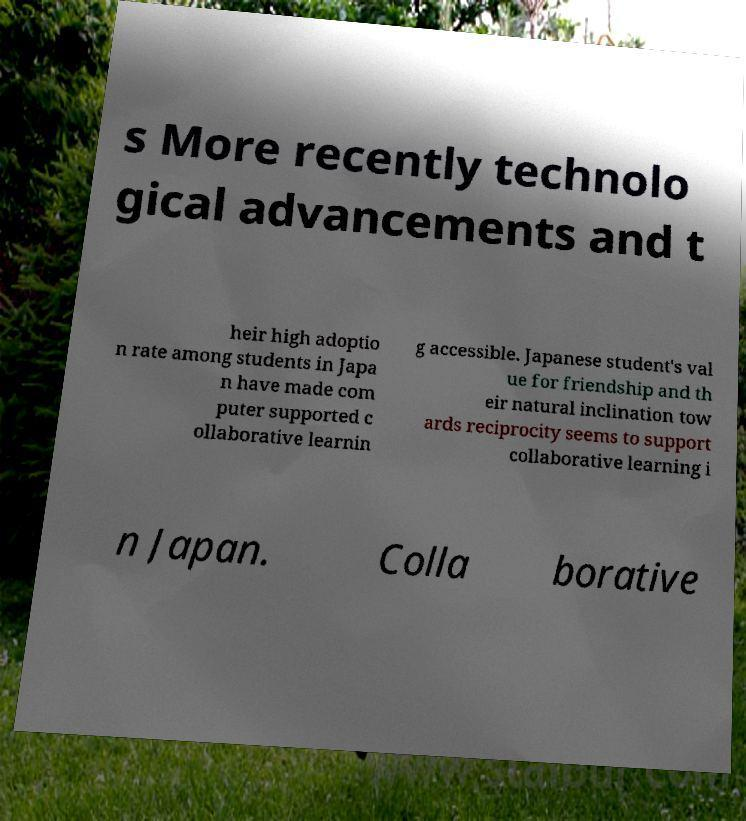Can you accurately transcribe the text from the provided image for me? s More recently technolo gical advancements and t heir high adoptio n rate among students in Japa n have made com puter supported c ollaborative learnin g accessible. Japanese student's val ue for friendship and th eir natural inclination tow ards reciprocity seems to support collaborative learning i n Japan. Colla borative 